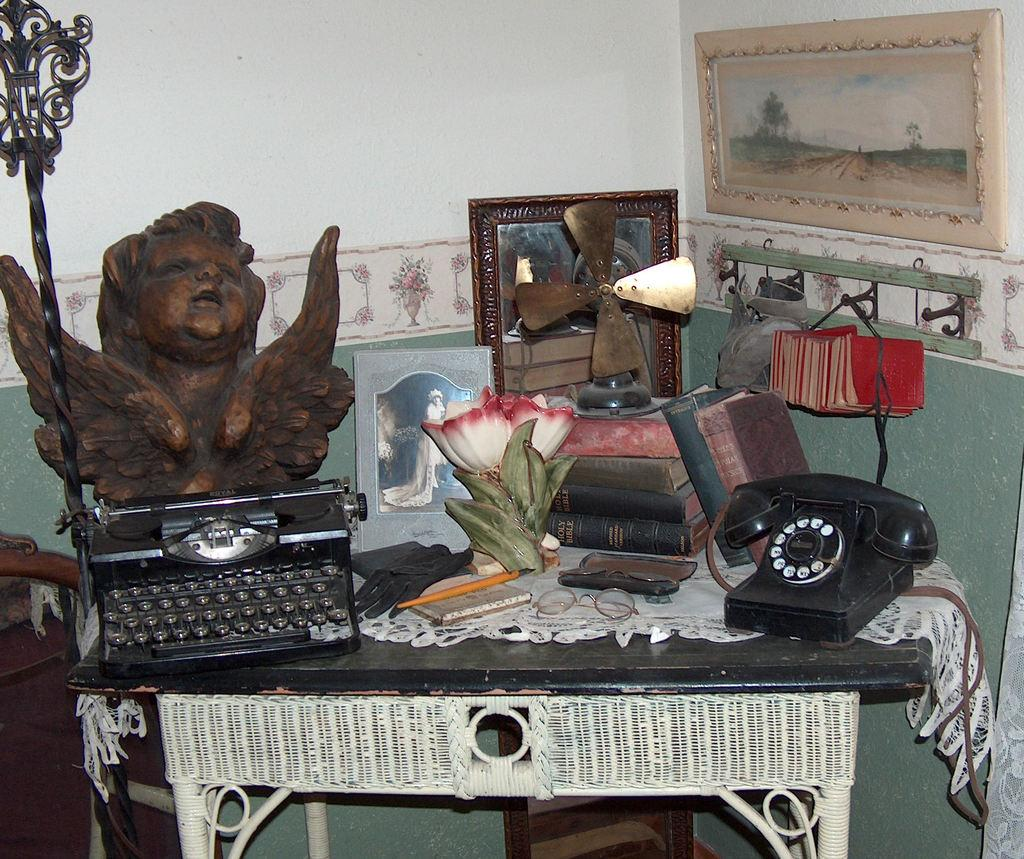What piece of furniture is present in the image? There is a table in the image. What object related to communication can be seen on the table? There is a telephone on the table. What type of items are present on the table for reading or learning? There are books on the table. What other objects can be seen on the table besides the telephone and books? There are some other objects on the table. What type of guitar is the grandfather playing in the image? There is no grandfather or guitar present in the image. 